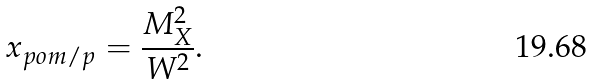<formula> <loc_0><loc_0><loc_500><loc_500>x _ { p o m / p } = \frac { M _ { X } ^ { 2 } } { W ^ { 2 } } .</formula> 